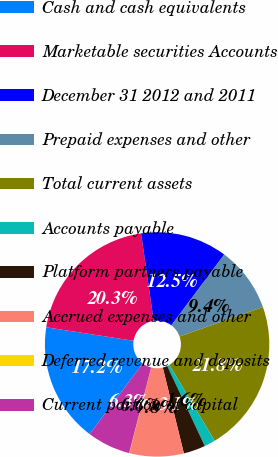Convert chart to OTSL. <chart><loc_0><loc_0><loc_500><loc_500><pie_chart><fcel>Cash and cash equivalents<fcel>Marketable securities Accounts<fcel>December 31 2012 and 2011<fcel>Prepaid expenses and other<fcel>Total current assets<fcel>Accounts payable<fcel>Platform partners payable<fcel>Accrued expenses and other<fcel>Deferred revenue and deposits<fcel>Current portion of capital<nl><fcel>17.17%<fcel>20.28%<fcel>12.49%<fcel>9.38%<fcel>21.84%<fcel>1.59%<fcel>3.15%<fcel>7.82%<fcel>0.03%<fcel>6.26%<nl></chart> 